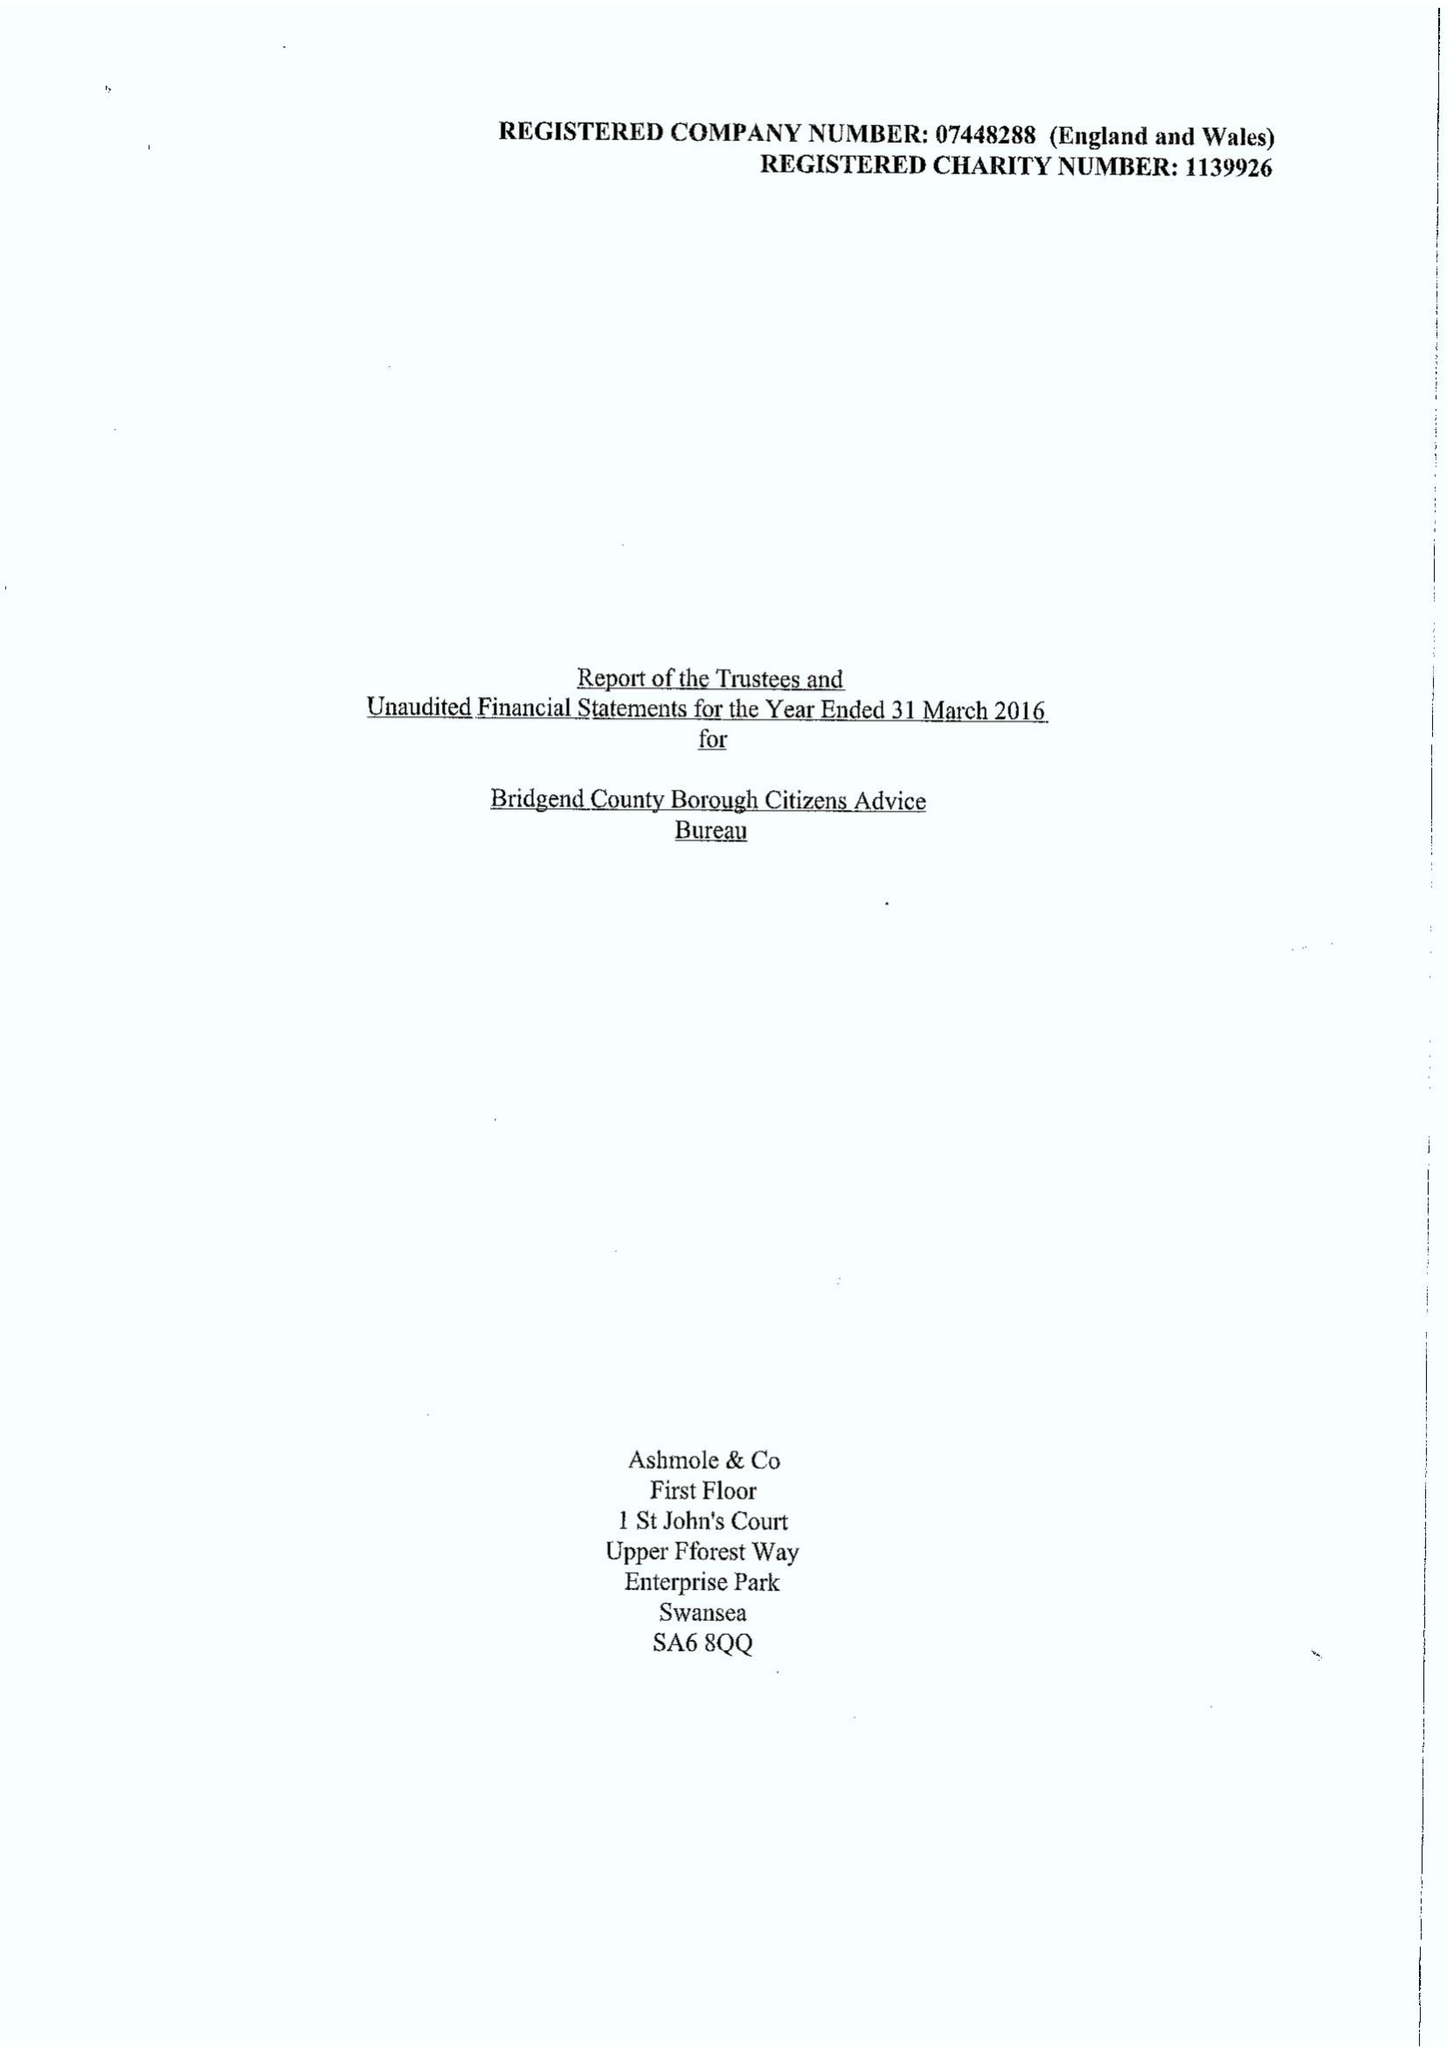What is the value for the charity_number?
Answer the question using a single word or phrase. 1139926 